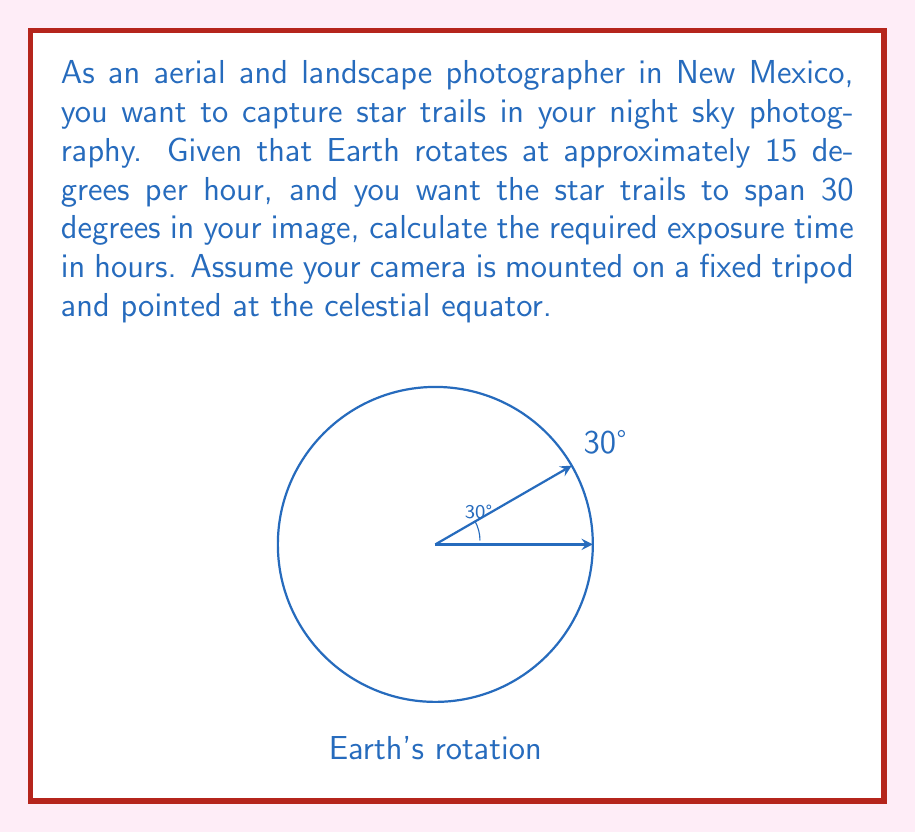What is the answer to this math problem? To solve this problem, we'll use the relationship between Earth's rotation rate and the desired angle of star trails:

1) Earth's rotation rate: 15 degrees per hour
2) Desired star trail angle: 30 degrees

We can set up a proportion:

$$ \frac{15 \text{ degrees}}{1 \text{ hour}} = \frac{30 \text{ degrees}}{x \text{ hours}} $$

Cross-multiply:

$$ 15x = 30 $$

Solve for x:

$$ x = \frac{30}{15} = 2 $$

Therefore, the exposure time needed to capture 30 degrees of star trails is 2 hours.

Note: This calculation assumes the camera is pointed at the celestial equator. For other pointing directions, the apparent motion of stars would be different, but the exposure time would remain the same for a given angular distance.
Answer: 2 hours 